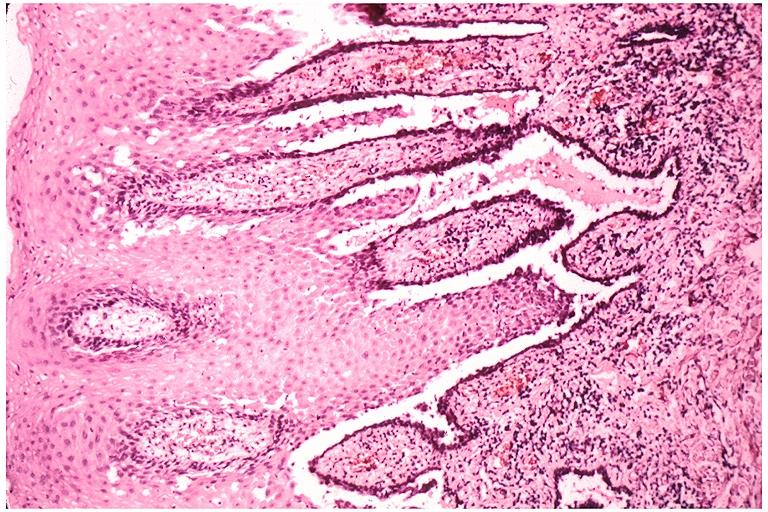s oral present?
Answer the question using a single word or phrase. Yes 